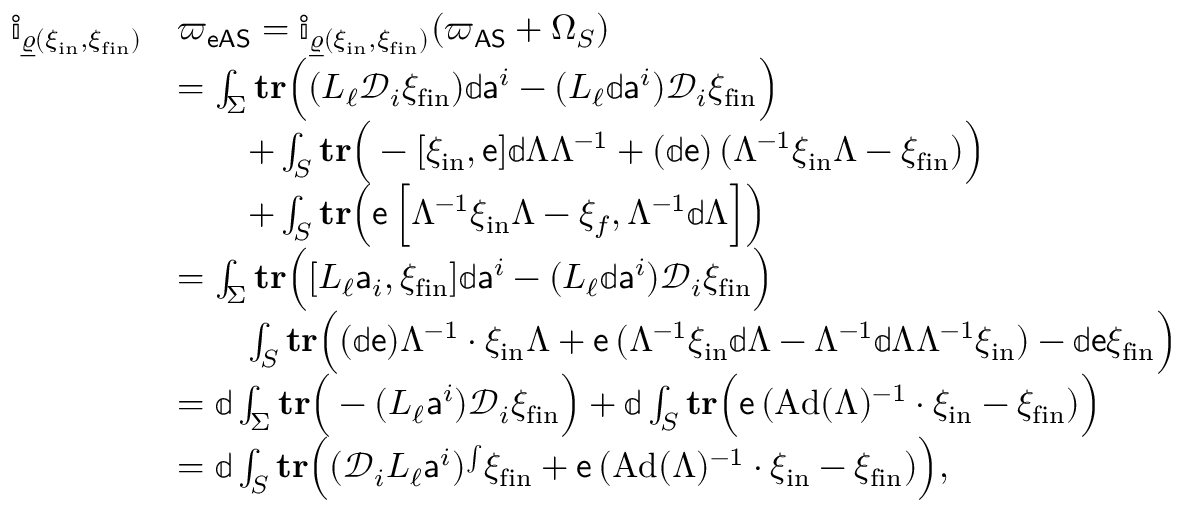Convert formula to latex. <formula><loc_0><loc_0><loc_500><loc_500>\begin{array} { r l } { \mathbb { i } _ { \underline { \varrho } ( \xi _ { i n } , \xi _ { f i n } ) } } & { { \varpi _ { e A S } } = \mathbb { i } _ { \underline { \varrho } ( \xi _ { i n } , \xi _ { f i n } ) } ( { \varpi _ { A S } } + \Omega _ { S } ) } \\ & { = \int _ { \Sigma } t r \left ( ( L _ { \ell } { \mathcal { D } } _ { i } \xi _ { f i n } ) \mathbb { d } { a } ^ { i } - ( L _ { \ell } \mathbb { d } { a } ^ { i } ) { \mathcal { D } } _ { i } \xi _ { f i n } \right ) } \\ & { \quad + \int _ { S } t r \left ( - [ \xi _ { i n } , { e } ] \mathbb { d } \Lambda \Lambda ^ { - 1 } + ( \mathbb { d } { e } ) \, ( \Lambda ^ { - 1 } \xi _ { i n } \Lambda - \xi _ { f i n } ) \right ) } \\ & { \quad + \int _ { S } t r \left ( { e } \, \left [ \Lambda ^ { - 1 } \xi _ { i n } \Lambda - \xi _ { f } , \Lambda ^ { - 1 } \mathbb { d } \Lambda \right ] \right ) } \\ & { = \int _ { \Sigma } t r \left ( [ L _ { \ell } { a } _ { i } , \xi _ { f i n } ] \mathbb { d } { a } ^ { i } - ( L _ { \ell } \mathbb { d } { a } ^ { i } ) { \mathcal { D } } _ { i } \xi _ { f i n } \right ) } \\ & { \quad \int _ { S } t r \left ( ( \mathbb { d } { e } ) \Lambda ^ { - 1 } \cdot \xi _ { i n } \Lambda + { e } \, ( \Lambda ^ { - 1 } \xi _ { i n } \mathbb { d } \Lambda - \Lambda ^ { - 1 } \mathbb { d } \Lambda \Lambda ^ { - 1 } \xi _ { i n } ) - \mathbb { d } { e } \xi _ { f i n } \right ) } \\ & { = \mathbb { d } \int _ { \Sigma } t r \left ( - ( L _ { \ell } { a } ^ { i } ) { \mathcal { D } } _ { i } \xi _ { f i n } \right ) + \mathbb { d } \int _ { S } t r \left ( { e } \, ( A d ( \Lambda ) ^ { - 1 } \cdot \xi _ { i n } - \xi _ { f i n } ) \right ) } \\ & { = \mathbb { d } \int _ { S } t r \left ( ( { \mathcal { D } } _ { i } L _ { \ell } { a } ^ { i } ) ^ { \int } \xi _ { f i n } + { e } \, ( A d ( \Lambda ) ^ { - 1 } \cdot \xi _ { i n } - \xi _ { f i n } ) \right ) , } \end{array}</formula> 